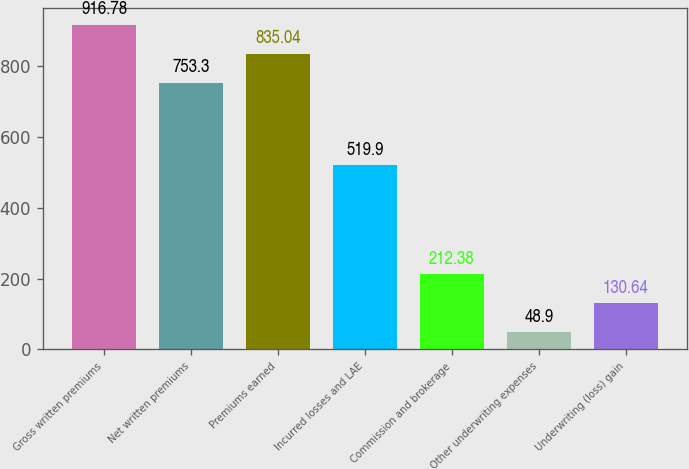Convert chart to OTSL. <chart><loc_0><loc_0><loc_500><loc_500><bar_chart><fcel>Gross written premiums<fcel>Net written premiums<fcel>Premiums earned<fcel>Incurred losses and LAE<fcel>Commission and brokerage<fcel>Other underwriting expenses<fcel>Underwriting (loss) gain<nl><fcel>916.78<fcel>753.3<fcel>835.04<fcel>519.9<fcel>212.38<fcel>48.9<fcel>130.64<nl></chart> 